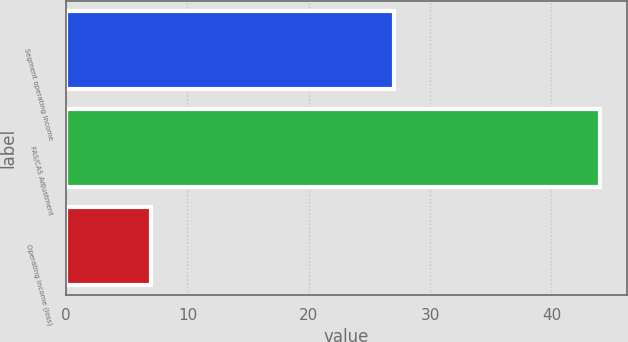<chart> <loc_0><loc_0><loc_500><loc_500><bar_chart><fcel>Segment operating income<fcel>FAS/CAS Adjustment<fcel>Operating income (loss)<nl><fcel>27<fcel>44<fcel>7<nl></chart> 